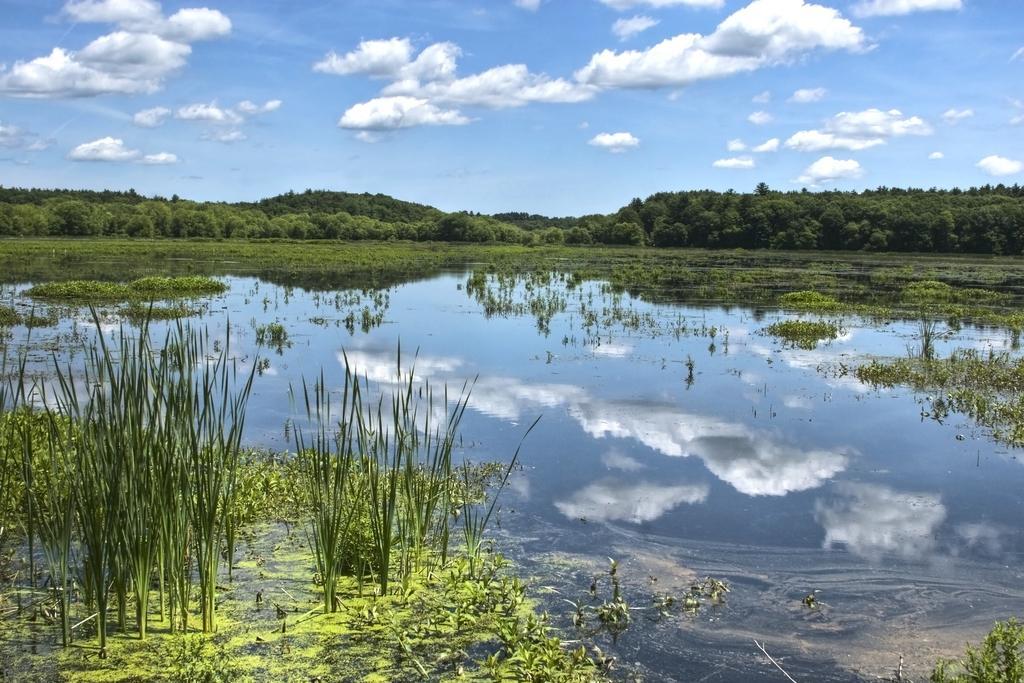Describe this image in one or two sentences. In this image we can see a few plants, grass, water and trees, in the background we can see the sky with clouds. 